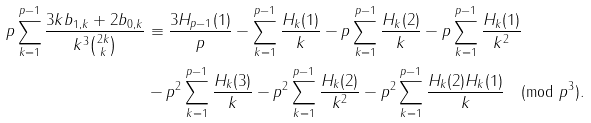Convert formula to latex. <formula><loc_0><loc_0><loc_500><loc_500>p \sum _ { k = 1 } ^ { p - 1 } \frac { 3 k b _ { 1 , k } + 2 b _ { 0 , k } } { k ^ { 3 } \binom { 2 k } { k } } & \equiv \frac { 3 H _ { p - 1 } ( 1 ) } { p } - \sum _ { k = 1 } ^ { p - 1 } \frac { H _ { k } ( 1 ) } { k } - p \sum _ { k = 1 } ^ { p - 1 } \frac { H _ { k } ( 2 ) } { k } - p \sum _ { k = 1 } ^ { p - 1 } \frac { H _ { k } ( 1 ) } { k ^ { 2 } } \\ & - p ^ { 2 } \sum _ { k = 1 } ^ { p - 1 } \frac { H _ { k } ( 3 ) } { k } - p ^ { 2 } \sum _ { k = 1 } ^ { p - 1 } \frac { H _ { k } ( 2 ) } { k ^ { 2 } } - p ^ { 2 } \sum _ { k = 1 } ^ { p - 1 } \frac { H _ { k } ( 2 ) H _ { k } ( 1 ) } { k } \pmod { p ^ { 3 } } .</formula> 